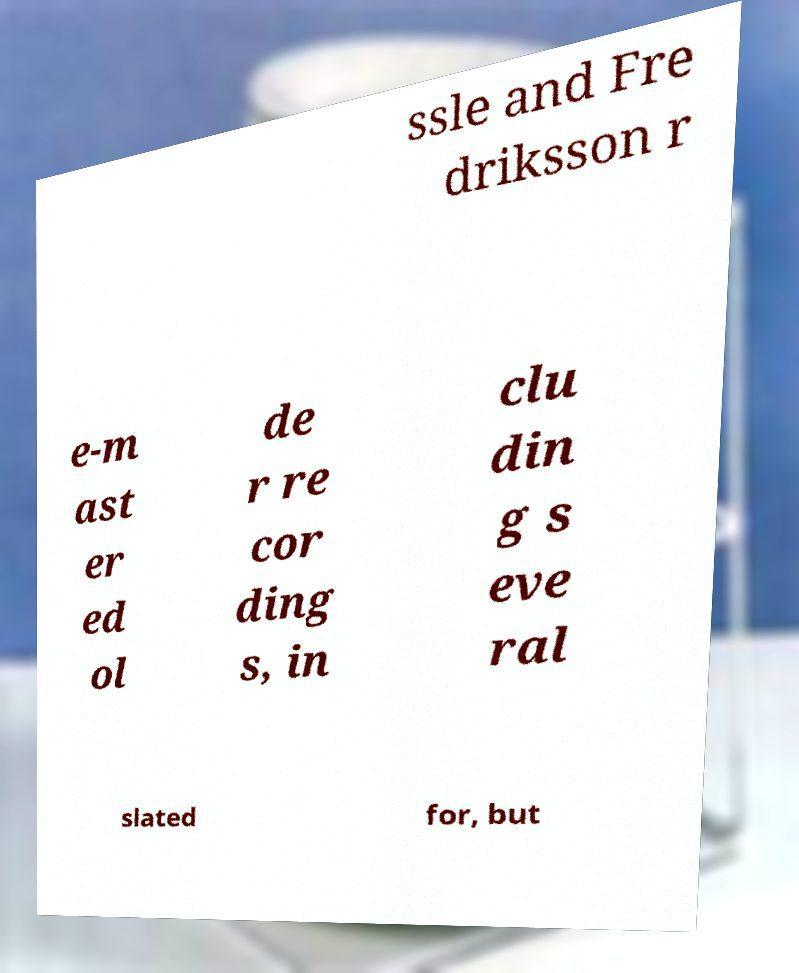For documentation purposes, I need the text within this image transcribed. Could you provide that? ssle and Fre driksson r e-m ast er ed ol de r re cor ding s, in clu din g s eve ral slated for, but 